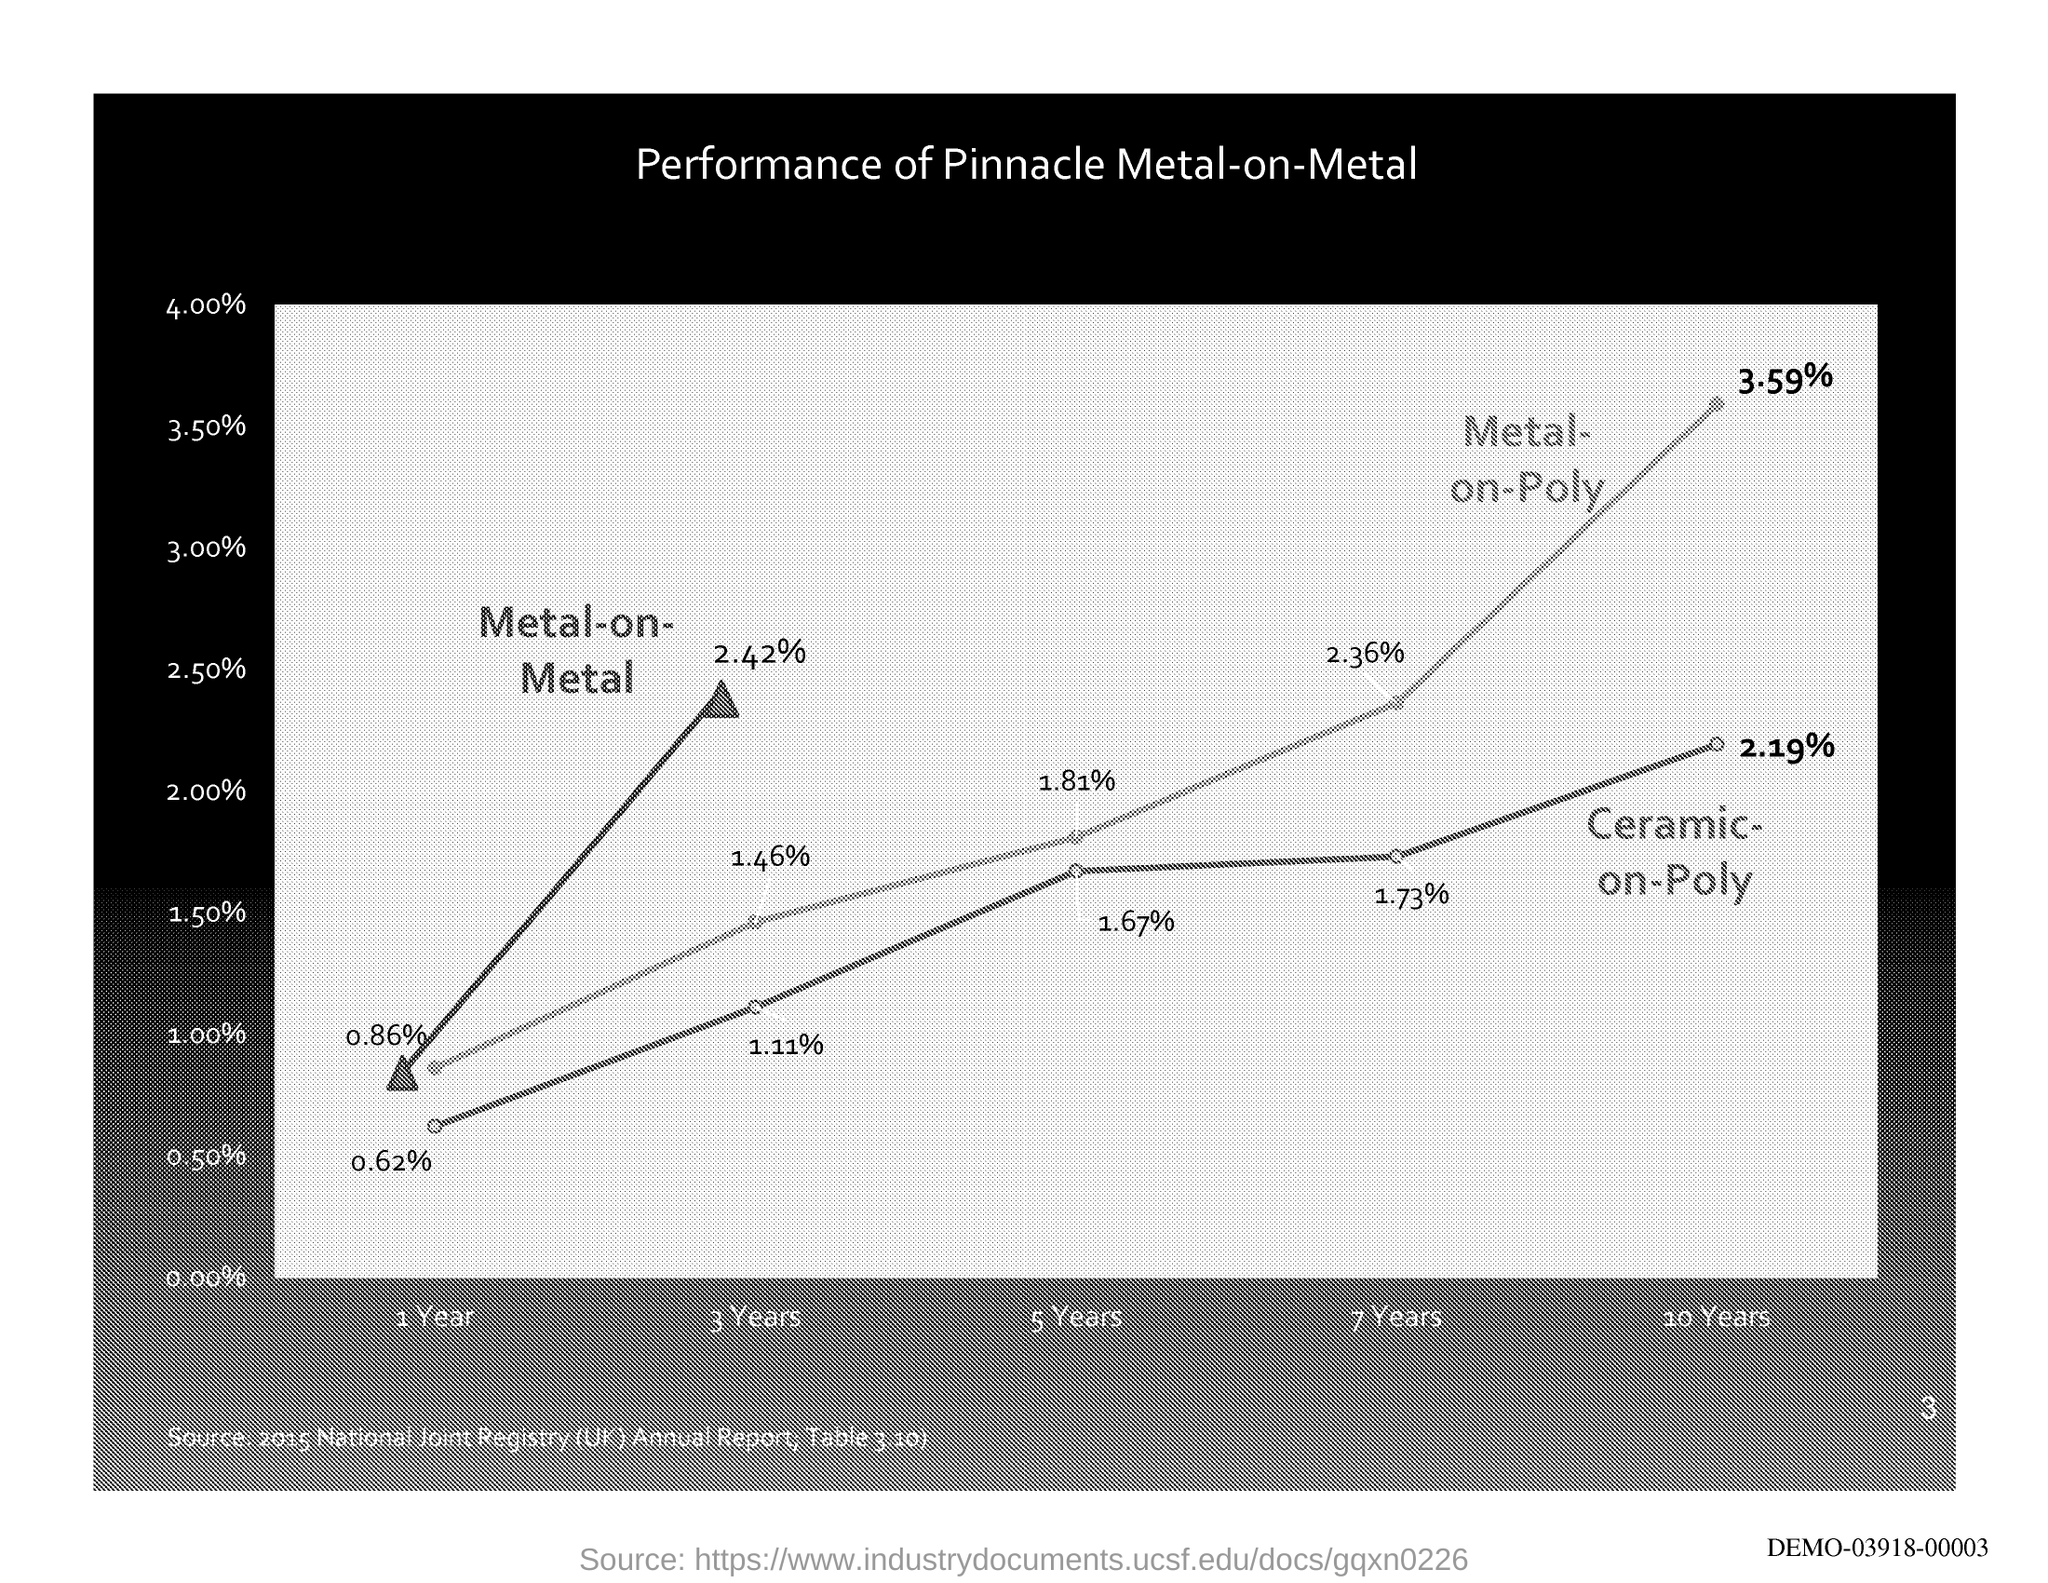What is the % of metal-on-metal for 1 year?
Keep it short and to the point. 0.86%. What is the % of metal-on-metal for 3 years?
Provide a succinct answer. 2.42%. What is the % of metal-on-poly for 3 years?
Keep it short and to the point. 1.46%. What is the % of metal-on-poly for 5 years?
Your answer should be very brief. 1.81%. 